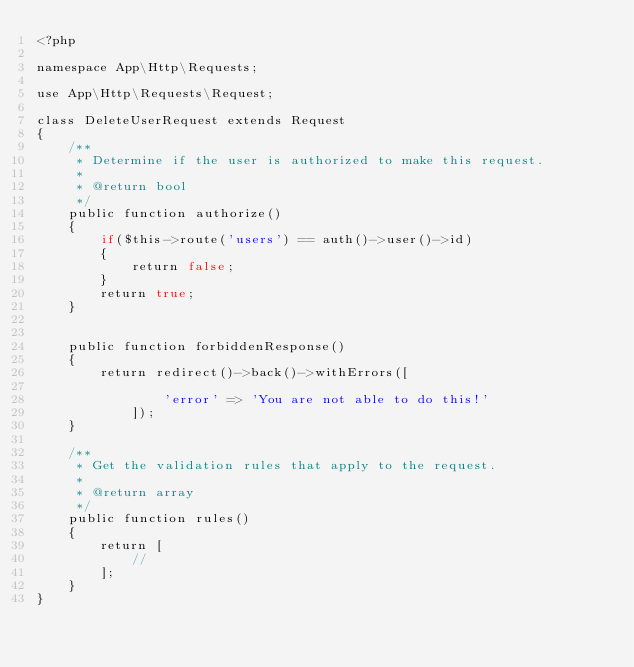Convert code to text. <code><loc_0><loc_0><loc_500><loc_500><_PHP_><?php

namespace App\Http\Requests;

use App\Http\Requests\Request;

class DeleteUserRequest extends Request
{
    /**
     * Determine if the user is authorized to make this request.
     *
     * @return bool
     */
    public function authorize()
    {
        if($this->route('users') == auth()->user()->id)
        {
            return false;
        }
        return true;
    }


    public function forbiddenResponse()
    {
        return redirect()->back()->withErrors([

                'error' => 'You are not able to do this!'
            ]);
    }

    /**
     * Get the validation rules that apply to the request.
     *
     * @return array
     */
    public function rules()
    {
        return [
            //
        ];
    }
}
</code> 